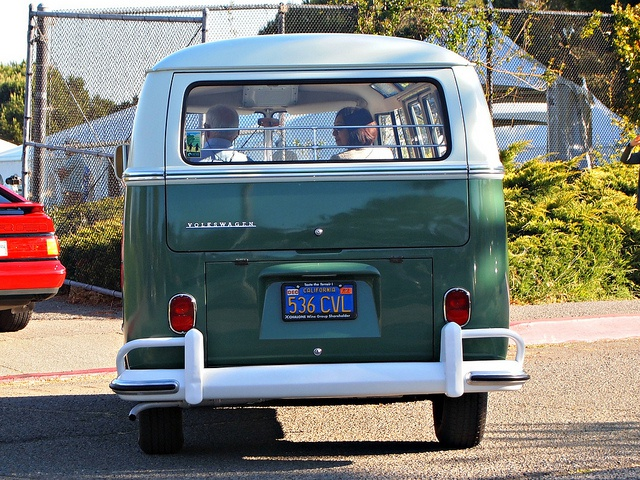Describe the objects in this image and their specific colors. I can see bus in white, black, blue, and lightblue tones, car in white, red, black, gray, and maroon tones, and people in white, gray, navy, and darkblue tones in this image. 